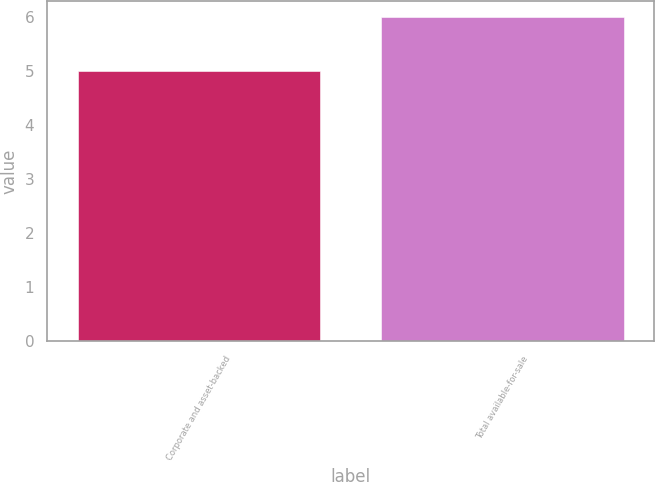<chart> <loc_0><loc_0><loc_500><loc_500><bar_chart><fcel>Corporate and asset-backed<fcel>Total available-for-sale<nl><fcel>5<fcel>6<nl></chart> 